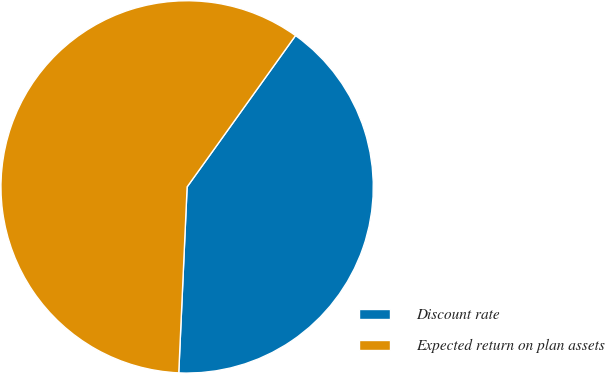Convert chart to OTSL. <chart><loc_0><loc_0><loc_500><loc_500><pie_chart><fcel>Discount rate<fcel>Expected return on plan assets<nl><fcel>40.82%<fcel>59.18%<nl></chart> 